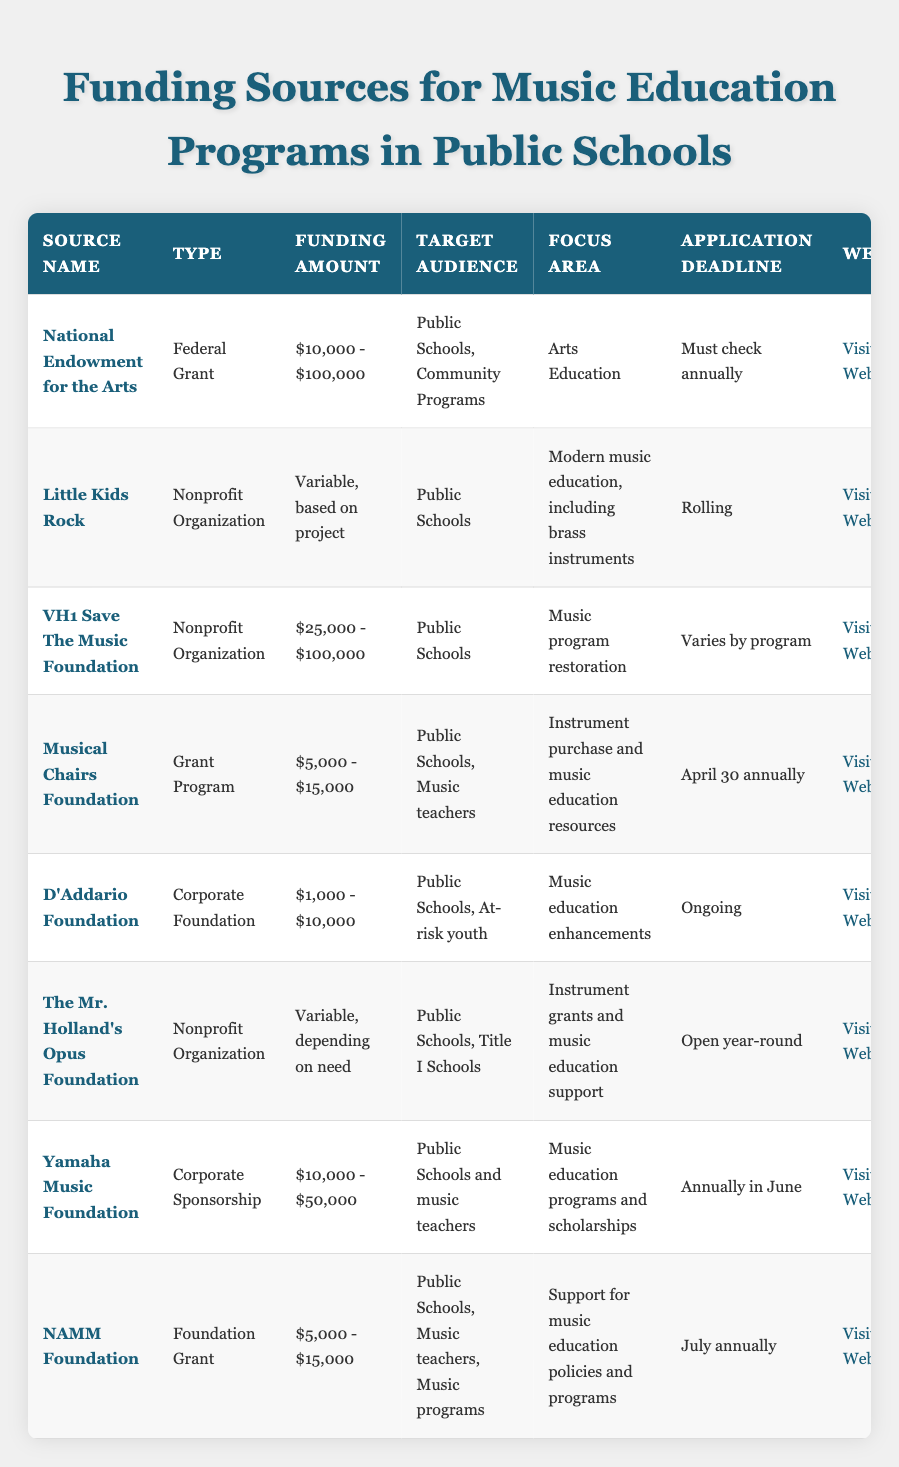What is the funding range provided by the National Endowment for the Arts? The National Endowment for the Arts lists its funding amount as "$10,000 - $100,000" in the Funding Amount column.
Answer: $10,000 - $100,000 Which organization focuses on modern music education and includes brass instruments? The table indicates that "Little Kids Rock" focuses on modern music education, including brass instruments, as stated in the Focus Area column.
Answer: Little Kids Rock What is the application deadline for the Musical Chairs Foundation? The application deadline for the Musical Chairs Foundation is listed as "April 30 annually" in the Application Deadline column.
Answer: April 30 annually Does the D'Addario Foundation specifically target at-risk youth? Yes, the D'Addario Foundation targets public schools and at-risk youth as indicated in the Target Audience column.
Answer: Yes What is the funding amount range for the VH1 Save The Music Foundation? The VH1 Save The Music Foundation has a funding amount range of "$25,000 - $100,000" as listed in the Funding Amount column.
Answer: $25,000 - $100,000 How many organizations listed provide funding amounts that are variable based on need or project? By reviewing the Funding Amount column, "Little Kids Rock" and "The Mr. Holland's Opus Foundation" both have variable amounts based on projects or needs. That totals to two organizations.
Answer: 2 Is there any funding source specifically for Title I schools? Yes, "The Mr. Holland's Opus Foundation" specifically targets Title I Schools as mentioned in the Target Audience column.
Answer: Yes Which organization has an application deadline that is open year-round? The Mr. Holland's Opus Foundation's application deadline is open year-round, as stated in the Application Deadline column.
Answer: The Mr. Holland's Opus Foundation What is the average funding amount range of the nonprofit organizations listed? The funding ranges are as follows: VH1 Save The Music Foundation ($25,000 - $100,000), Little Kids Rock (Variable), and The Mr. Holland's Opus Foundation (Variable). Since two are variable, we can't average them, leading to an indeterminate average for the exact ranges available. The only definite average involves VH1.
Answer: Indeterminate Among the foundations listed, which has a website link provided? All organizations listed have a website link in the Website column, so they all provide links for more information.
Answer: All have a website link 